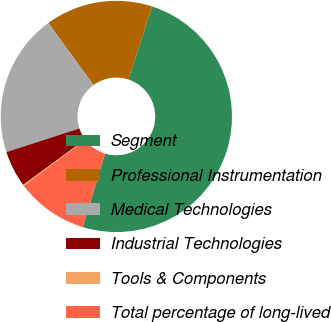<chart> <loc_0><loc_0><loc_500><loc_500><pie_chart><fcel>Segment<fcel>Professional Instrumentation<fcel>Medical Technologies<fcel>Industrial Technologies<fcel>Tools & Components<fcel>Total percentage of long-lived<nl><fcel>49.7%<fcel>15.01%<fcel>19.97%<fcel>5.1%<fcel>0.15%<fcel>10.06%<nl></chart> 